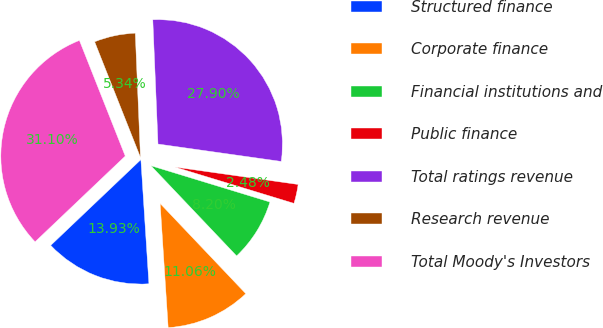<chart> <loc_0><loc_0><loc_500><loc_500><pie_chart><fcel>Structured finance<fcel>Corporate finance<fcel>Financial institutions and<fcel>Public finance<fcel>Total ratings revenue<fcel>Research revenue<fcel>Total Moody's Investors<nl><fcel>13.93%<fcel>11.06%<fcel>8.2%<fcel>2.48%<fcel>27.9%<fcel>5.34%<fcel>31.1%<nl></chart> 